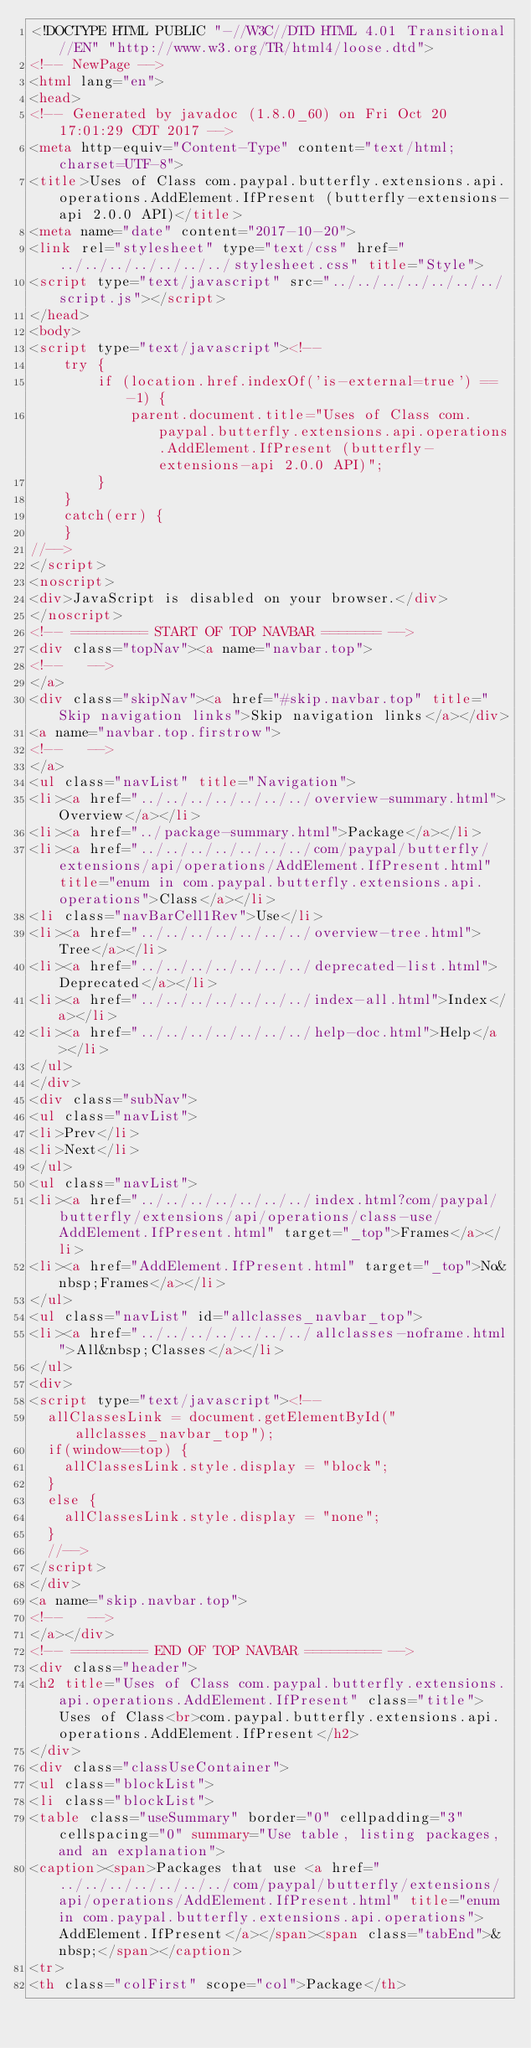Convert code to text. <code><loc_0><loc_0><loc_500><loc_500><_HTML_><!DOCTYPE HTML PUBLIC "-//W3C//DTD HTML 4.01 Transitional//EN" "http://www.w3.org/TR/html4/loose.dtd">
<!-- NewPage -->
<html lang="en">
<head>
<!-- Generated by javadoc (1.8.0_60) on Fri Oct 20 17:01:29 CDT 2017 -->
<meta http-equiv="Content-Type" content="text/html; charset=UTF-8">
<title>Uses of Class com.paypal.butterfly.extensions.api.operations.AddElement.IfPresent (butterfly-extensions-api 2.0.0 API)</title>
<meta name="date" content="2017-10-20">
<link rel="stylesheet" type="text/css" href="../../../../../../../stylesheet.css" title="Style">
<script type="text/javascript" src="../../../../../../../script.js"></script>
</head>
<body>
<script type="text/javascript"><!--
    try {
        if (location.href.indexOf('is-external=true') == -1) {
            parent.document.title="Uses of Class com.paypal.butterfly.extensions.api.operations.AddElement.IfPresent (butterfly-extensions-api 2.0.0 API)";
        }
    }
    catch(err) {
    }
//-->
</script>
<noscript>
<div>JavaScript is disabled on your browser.</div>
</noscript>
<!-- ========= START OF TOP NAVBAR ======= -->
<div class="topNav"><a name="navbar.top">
<!--   -->
</a>
<div class="skipNav"><a href="#skip.navbar.top" title="Skip navigation links">Skip navigation links</a></div>
<a name="navbar.top.firstrow">
<!--   -->
</a>
<ul class="navList" title="Navigation">
<li><a href="../../../../../../../overview-summary.html">Overview</a></li>
<li><a href="../package-summary.html">Package</a></li>
<li><a href="../../../../../../../com/paypal/butterfly/extensions/api/operations/AddElement.IfPresent.html" title="enum in com.paypal.butterfly.extensions.api.operations">Class</a></li>
<li class="navBarCell1Rev">Use</li>
<li><a href="../../../../../../../overview-tree.html">Tree</a></li>
<li><a href="../../../../../../../deprecated-list.html">Deprecated</a></li>
<li><a href="../../../../../../../index-all.html">Index</a></li>
<li><a href="../../../../../../../help-doc.html">Help</a></li>
</ul>
</div>
<div class="subNav">
<ul class="navList">
<li>Prev</li>
<li>Next</li>
</ul>
<ul class="navList">
<li><a href="../../../../../../../index.html?com/paypal/butterfly/extensions/api/operations/class-use/AddElement.IfPresent.html" target="_top">Frames</a></li>
<li><a href="AddElement.IfPresent.html" target="_top">No&nbsp;Frames</a></li>
</ul>
<ul class="navList" id="allclasses_navbar_top">
<li><a href="../../../../../../../allclasses-noframe.html">All&nbsp;Classes</a></li>
</ul>
<div>
<script type="text/javascript"><!--
  allClassesLink = document.getElementById("allclasses_navbar_top");
  if(window==top) {
    allClassesLink.style.display = "block";
  }
  else {
    allClassesLink.style.display = "none";
  }
  //-->
</script>
</div>
<a name="skip.navbar.top">
<!--   -->
</a></div>
<!-- ========= END OF TOP NAVBAR ========= -->
<div class="header">
<h2 title="Uses of Class com.paypal.butterfly.extensions.api.operations.AddElement.IfPresent" class="title">Uses of Class<br>com.paypal.butterfly.extensions.api.operations.AddElement.IfPresent</h2>
</div>
<div class="classUseContainer">
<ul class="blockList">
<li class="blockList">
<table class="useSummary" border="0" cellpadding="3" cellspacing="0" summary="Use table, listing packages, and an explanation">
<caption><span>Packages that use <a href="../../../../../../../com/paypal/butterfly/extensions/api/operations/AddElement.IfPresent.html" title="enum in com.paypal.butterfly.extensions.api.operations">AddElement.IfPresent</a></span><span class="tabEnd">&nbsp;</span></caption>
<tr>
<th class="colFirst" scope="col">Package</th></code> 